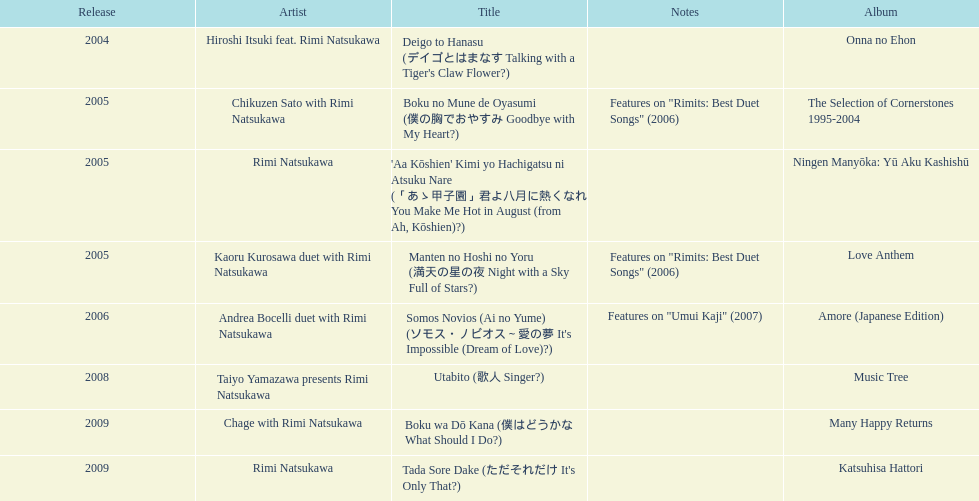Out of onna no ehon and music tree, which one did not come out in 2004? Music Tree. Give me the full table as a dictionary. {'header': ['Release', 'Artist', 'Title', 'Notes', 'Album'], 'rows': [['2004', 'Hiroshi Itsuki feat. Rimi Natsukawa', "Deigo to Hanasu (デイゴとはまなす Talking with a Tiger's Claw Flower?)", '', 'Onna no Ehon'], ['2005', 'Chikuzen Sato with Rimi Natsukawa', 'Boku no Mune de Oyasumi (僕の胸でおやすみ Goodbye with My Heart?)', 'Features on "Rimits: Best Duet Songs" (2006)', 'The Selection of Cornerstones 1995-2004'], ['2005', 'Rimi Natsukawa', "'Aa Kōshien' Kimi yo Hachigatsu ni Atsuku Nare (「あゝ甲子園」君よ八月に熱くなれ You Make Me Hot in August (from Ah, Kōshien)?)", '', 'Ningen Manyōka: Yū Aku Kashishū'], ['2005', 'Kaoru Kurosawa duet with Rimi Natsukawa', 'Manten no Hoshi no Yoru (満天の星の夜 Night with a Sky Full of Stars?)', 'Features on "Rimits: Best Duet Songs" (2006)', 'Love Anthem'], ['2006', 'Andrea Bocelli duet with Rimi Natsukawa', "Somos Novios (Ai no Yume) (ソモス・ノビオス～愛の夢 It's Impossible (Dream of Love)?)", 'Features on "Umui Kaji" (2007)', 'Amore (Japanese Edition)'], ['2008', 'Taiyo Yamazawa presents Rimi Natsukawa', 'Utabito (歌人 Singer?)', '', 'Music Tree'], ['2009', 'Chage with Rimi Natsukawa', 'Boku wa Dō Kana (僕はどうかな What Should I Do?)', '', 'Many Happy Returns'], ['2009', 'Rimi Natsukawa', "Tada Sore Dake (ただそれだけ It's Only That?)", '', 'Katsuhisa Hattori']]} 